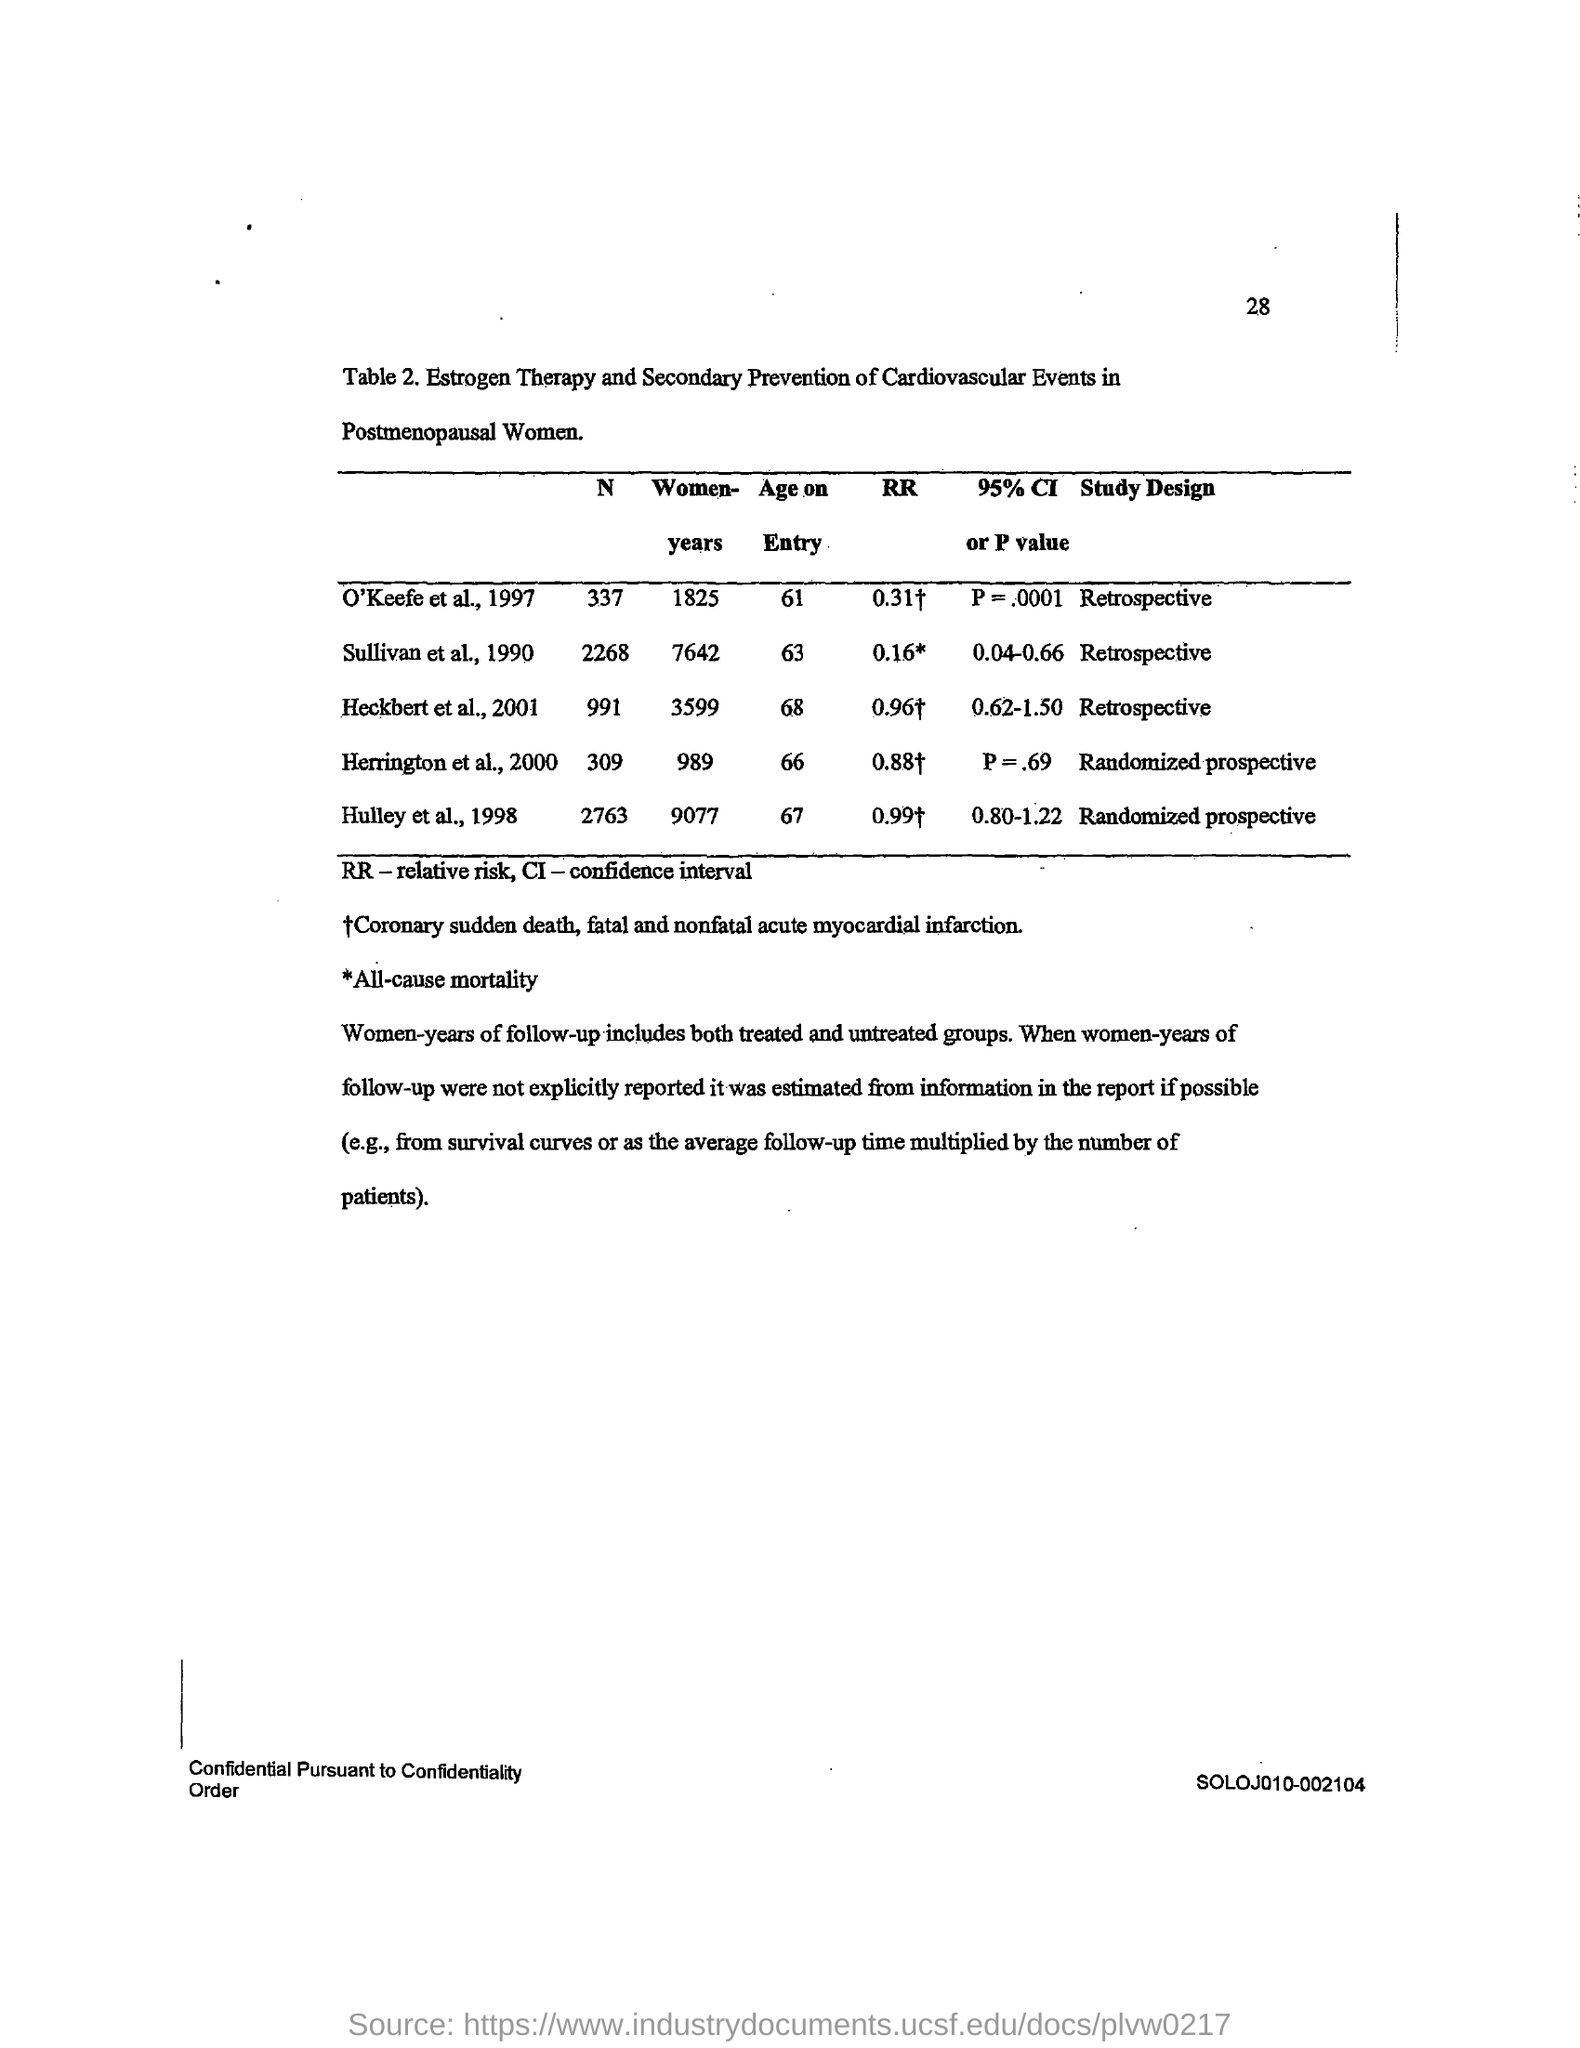What is the age on entry value for o'keefe et al; 1997 ?
Keep it short and to the point. 61. What is the study design of sullivan et al; 1990 ?
Keep it short and to the point. Retrospective. What is the full form of rr ?
Give a very brief answer. Relative risk. What is the rr value for hulleyet al; 1998 ?
Keep it short and to the point. 0.99. What is the age on entry value for heckbert et al ;2001 ?
Your response must be concise. 68. What is the study design for herrington et al;2000 ?
Ensure brevity in your answer.  Randomized prospective. 